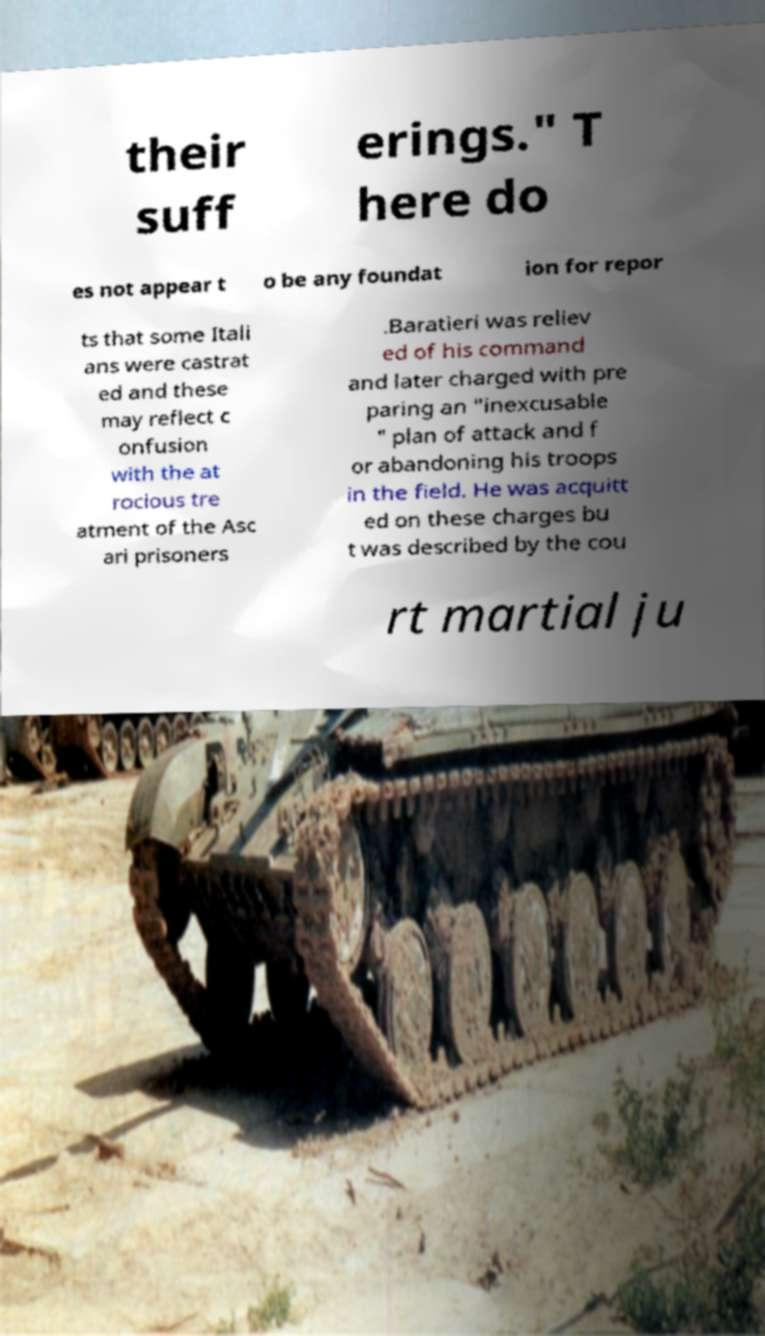I need the written content from this picture converted into text. Can you do that? their suff erings." T here do es not appear t o be any foundat ion for repor ts that some Itali ans were castrat ed and these may reflect c onfusion with the at rocious tre atment of the Asc ari prisoners .Baratieri was reliev ed of his command and later charged with pre paring an "inexcusable " plan of attack and f or abandoning his troops in the field. He was acquitt ed on these charges bu t was described by the cou rt martial ju 